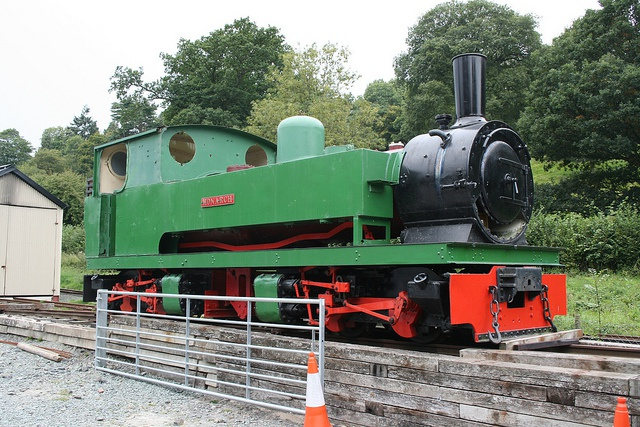Describe the objects in this image and their specific colors. I can see a train in white, black, green, gray, and turquoise tones in this image. 